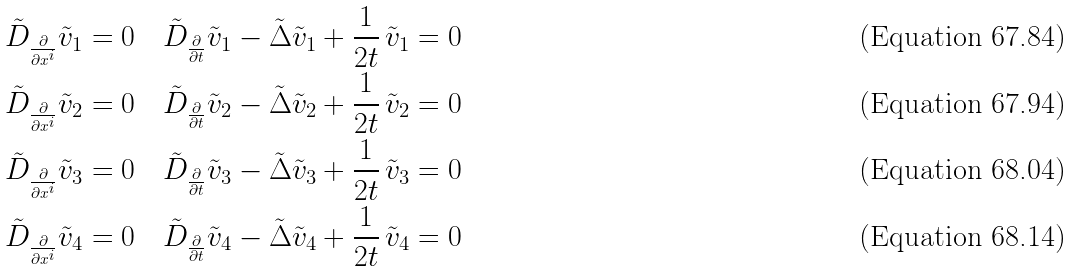Convert formula to latex. <formula><loc_0><loc_0><loc_500><loc_500>& \tilde { D } _ { \frac { \partial } { \partial x ^ { i } } } \tilde { v } _ { 1 } = 0 \quad \tilde { D } _ { \frac { \partial } { \partial t } } \tilde { v } _ { 1 } - \tilde { \Delta } \tilde { v } _ { 1 } + \frac { 1 } { 2 t } \, \tilde { v } _ { 1 } = 0 \\ & \tilde { D } _ { \frac { \partial } { \partial x ^ { i } } } \tilde { v } _ { 2 } = 0 \quad \tilde { D } _ { \frac { \partial } { \partial t } } \tilde { v } _ { 2 } - \tilde { \Delta } \tilde { v } _ { 2 } + \frac { 1 } { 2 t } \, \tilde { v } _ { 2 } = 0 \\ & \tilde { D } _ { \frac { \partial } { \partial x ^ { i } } } \tilde { v } _ { 3 } = 0 \quad \tilde { D } _ { \frac { \partial } { \partial t } } \tilde { v } _ { 3 } - \tilde { \Delta } \tilde { v } _ { 3 } + \frac { 1 } { 2 t } \, \tilde { v } _ { 3 } = 0 \\ & \tilde { D } _ { \frac { \partial } { \partial x ^ { i } } } \tilde { v } _ { 4 } = 0 \quad \tilde { D } _ { \frac { \partial } { \partial t } } \tilde { v } _ { 4 } - \tilde { \Delta } \tilde { v } _ { 4 } + \frac { 1 } { 2 t } \, \tilde { v } _ { 4 } = 0</formula> 